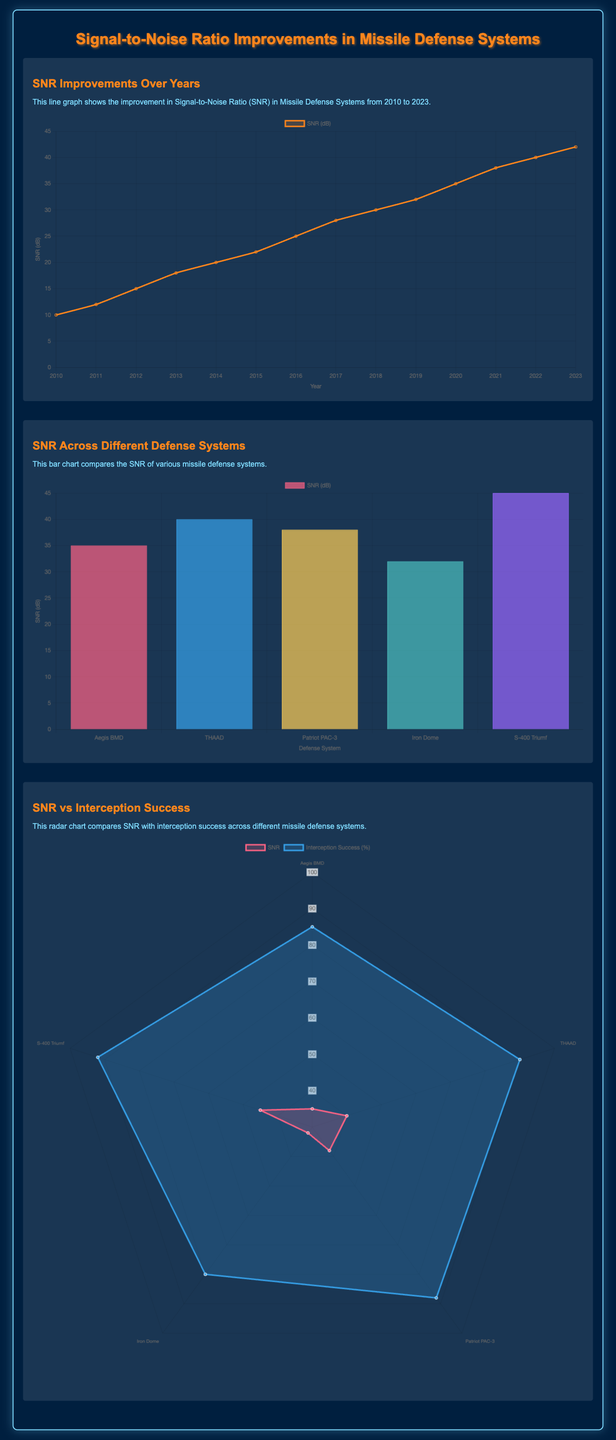What was the SNR in 2010? The SNR in 2010 is noted in the line graph's dataset, which shows an initial value of 10 dB.
Answer: 10 dB What is the highest SNR among the defense systems? The bar chart compares various missile defense systems and indicates that the S-400 Triumf has the highest SNR value of 45 dB.
Answer: 45 dB Which year shows a significant increase in SNR? A significant increase in SNR can be observed in 2015 when the value rose from 22 dB in 2014 to 25 dB.
Answer: 2015 What is the SNR of THAAD? The bar chart provides a specific SNR value for THAAD, which is shown to be 40 dB.
Answer: 40 dB Which defense system has the lowest interception success percentage? The radar chart indicates that Iron Dome has the lowest interception success percentage, recorded at 80%.
Answer: 80% What year showed the maximum SNR value in the data? The line graph illustrates that 2023 is the year with the maximum SNR value of 42 dB.
Answer: 2023 How many defense systems are compared in the SNR chart? The bar chart indicates that five defense systems are compared in the document.
Answer: Five In which year did the SNR reach 35 dB? According to the line graph, the SNR reached 35 dB in the year 2020.
Answer: 2020 What is the interception success for the S-400 Triumf? The radar chart provides the interception success percentage for S-400 Triumf, which is shown as 92%.
Answer: 92% 